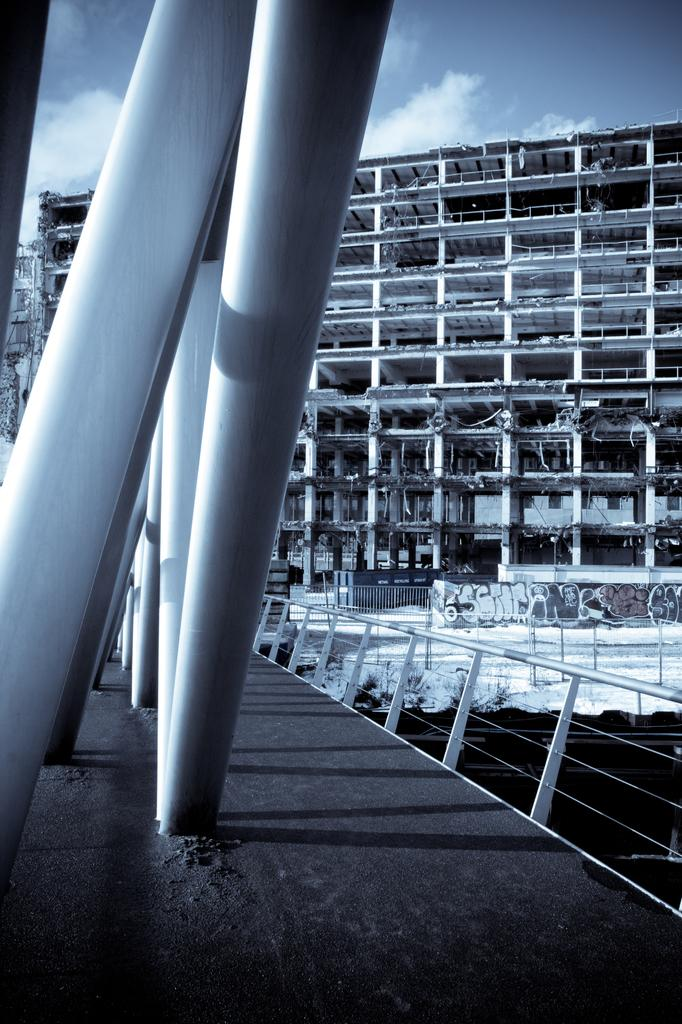What structure is located at the bottom of the image? There is a bridge at the bottom of the image. What can be seen in the background of the image? There is a building in the background of the image. What is visible at the top of the image? The sky is visible at the top of the image. How many nails can be seen holding the bridge together in the image? There are no nails visible in the image; the bridge's construction is not detailed. What is the back of the building in the image like? The back of the building is not visible in the image, as only the front is shown. 